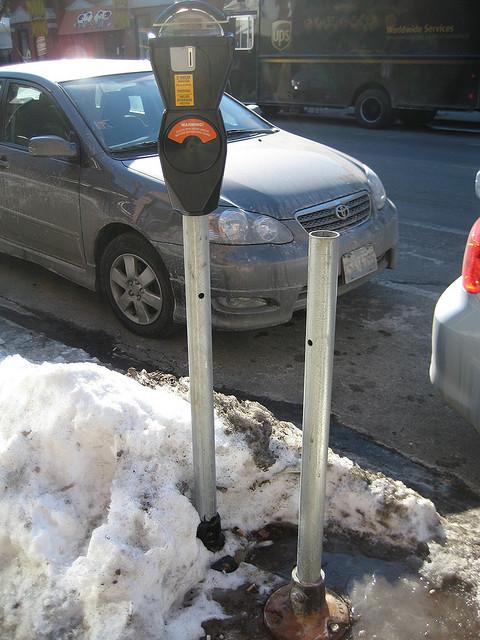How much is the meter?
Concise answer only. 0. What kind of vehicle is this?
Concise answer only. Car. Is the snow melting?
Keep it brief. Yes. 